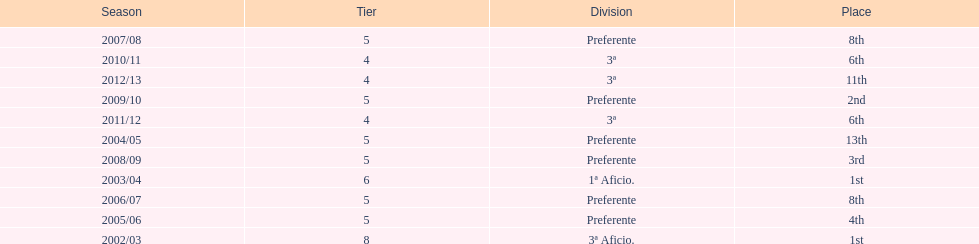How many years was the team in the 3 a division? 4. 